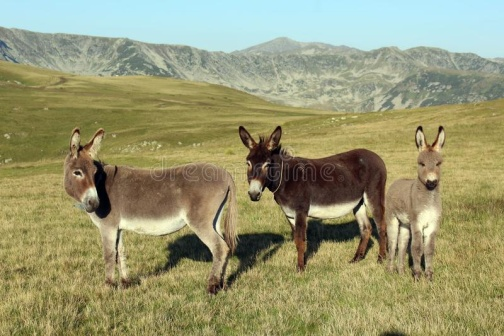Please describe the mood and atmosphere of the image in a more creative manner. The image radiates a tranquil and serene atmosphere, weaving a tapestry of pastoral peace. The trio of donkeys stand as silent sentinels in this picturesque field, under the watchful gaze of the towering, rugged mountains that cradle them. The vibrant green of the grass contrasts beautifully with the earthy tones of the donkeys and the muted, majestic hues of the distant rocky crags, creating a harmonious blend between flora and fauna. This scene offers a glimpse into a world untroubled by the hustle of human life, a simple but profound sanctuary in the lap of nature. 